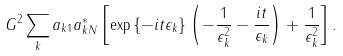<formula> <loc_0><loc_0><loc_500><loc_500>G ^ { 2 } \sum _ { k } a _ { k 1 } a _ { k N } ^ { * } \left [ \exp \left \{ - i t \epsilon _ { k } \right \} \left ( - \frac { 1 } { \epsilon _ { k } ^ { 2 } } - \frac { i t } { \epsilon _ { k } } \right ) + \frac { 1 } { \epsilon _ { k } ^ { 2 } } \right ] .</formula> 